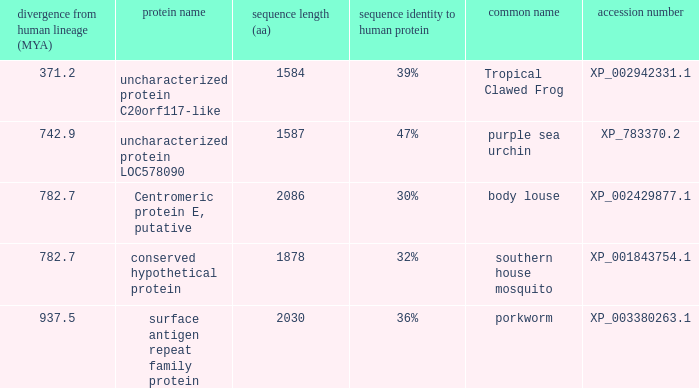What is the sequence length (aa) of the protein with the common name Purple Sea Urchin and a divergence from human lineage less than 742.9? None. 